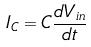Convert formula to latex. <formula><loc_0><loc_0><loc_500><loc_500>I _ { C } = C \frac { d V _ { i n } } { d t }</formula> 